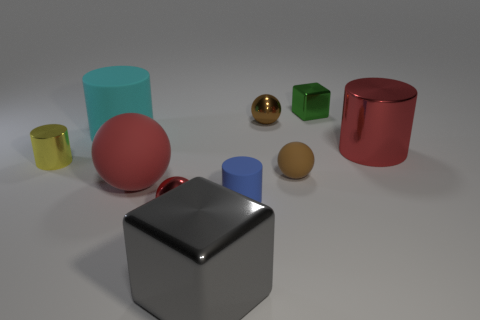What number of objects are either big objects in front of the small rubber cylinder or big things behind the tiny metal cylinder?
Make the answer very short. 3. What number of tiny red metal things have the same shape as the brown rubber thing?
Your answer should be very brief. 1. What is the color of the rubber ball that is the same size as the cyan thing?
Offer a very short reply. Red. What color is the big thing behind the large red object that is on the right side of the cube to the right of the small blue rubber thing?
Give a very brief answer. Cyan. There is a red metallic ball; does it have the same size as the metal cylinder on the right side of the tiny red thing?
Your response must be concise. No. How many things are either matte cylinders or cylinders?
Your response must be concise. 4. Are there any small red objects made of the same material as the tiny yellow object?
Ensure brevity in your answer.  Yes. What is the size of the other metal sphere that is the same color as the big sphere?
Make the answer very short. Small. The thing in front of the small shiny sphere in front of the cyan object is what color?
Your answer should be compact. Gray. Is the size of the red rubber thing the same as the cyan cylinder?
Give a very brief answer. Yes. 